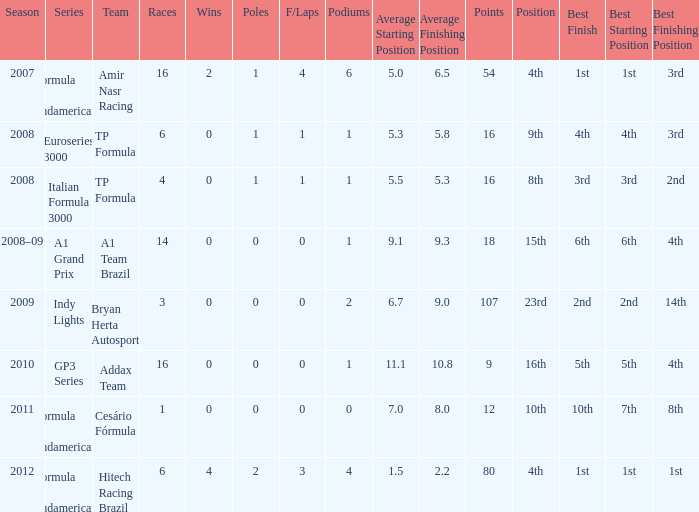Which group did he contend for in the gp3 series? Addax Team. 